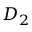Convert formula to latex. <formula><loc_0><loc_0><loc_500><loc_500>D _ { 2 }</formula> 